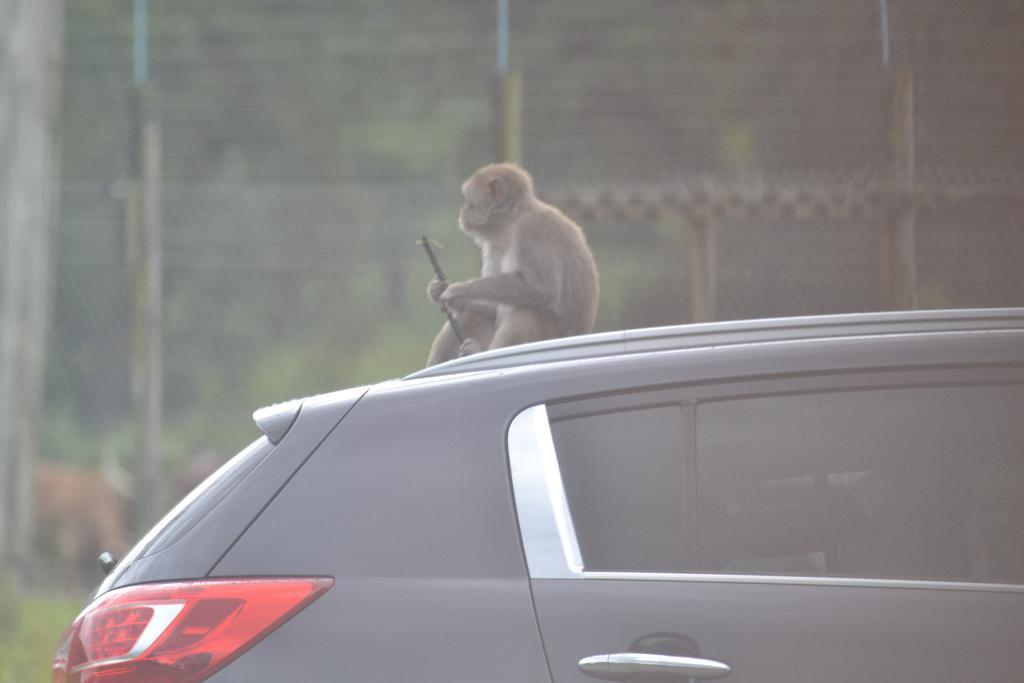What type of vehicle is in the image? There is a black car in the image. What is sitting on the car? A monkey is sitting on the car. What can be seen in the background of the image? There is a wall in the background of the image. What color is the heart of the monkey in the image? There is no heart visible in the image, as it is a photograph of a monkey sitting on a car. 